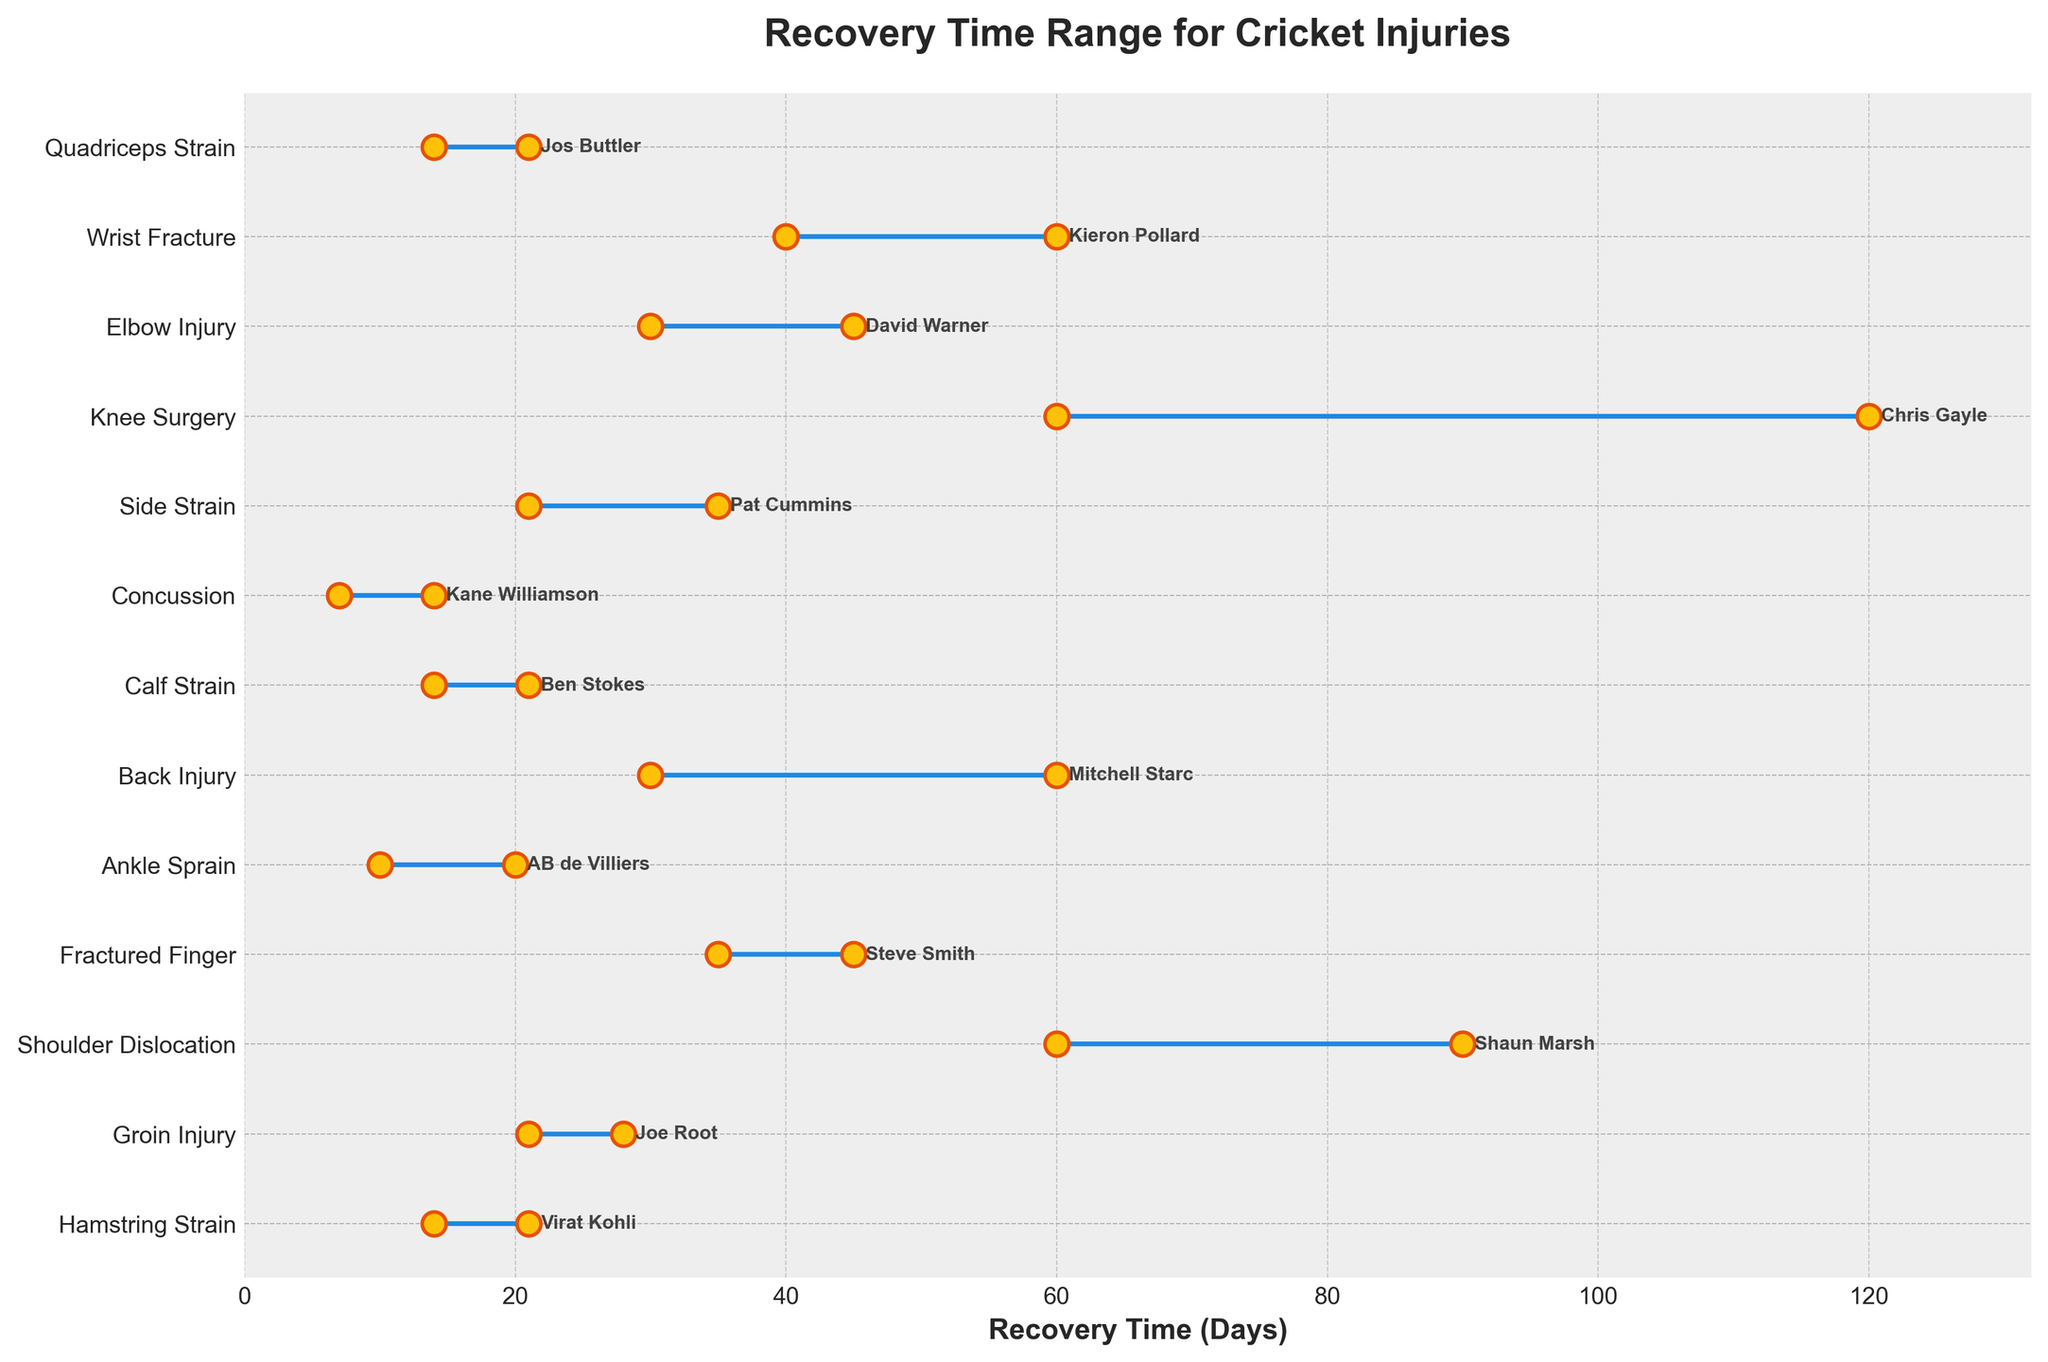What injury type has the longest maximum recovery time? To find the injury type with the longest maximum recovery time, look at the right endpoint of the ranges. The injury type with the highest maximum value is Knee Surgery, which has a maximum recovery time of 120 days.
Answer: Knee Surgery What is the shortest minimum recovery time shown in the plot? To find the shortest minimum recovery time, look at the left endpoint of the ranges. The lowest minimum recovery time is for Concussion, which is 7 days.
Answer: Concussion Which player has the broadest range of recovery times, and what is that range? To find the player with the broadest range, calculate the difference between the maximum and minimum recovery times for each player. The largest difference is for Chris Gayle (Knee Surgery), spanning from 60 to 120 days, which is a range of 60 days.
Answer: Chris Gayle, 60 days How many injury types have a maximum recovery time of more than 60 days? Count the number of injuries with a maximum recovery time greater than 60 days. These include Shoulder Dislocation, Knee Surgery, Back Injury, and Wrist Fracture, totaling 4 injury types.
Answer: 4 injury types Which player's recovery times wholly fit within the 10 to 20 days range? Look at the players whose minimum and maximum recovery times are between 10 and 20 days. Both AB de Villiers (Ankle Sprain) and Kane Williamson (Concussion) have recovery times that fit within this range.
Answer: AB de Villiers, Kane Williamson Calculate the average maximum recovery time for Fractured Finger and Wrist Fracture. First, identify the maximum recovery times: Fractured Finger (45 days), Wrist Fracture (60 days). Sum these maximum times (45 + 60 = 105) and divide by 2 to get the average: 105 / 2 = 52.5 days.
Answer: 52.5 days Compared to Ben Stokes (Calf Strain), how much longer is Mitchell Starc's (Back Injury) maximum recovery time? Find the difference between Mitchell Starc's maximum recovery time (60 days) and Ben Stokes' maximum recovery time (21 days). The difference is 60 - 21 = 39 days.
Answer: 39 days What is the median maximum recovery time of all injuries? List the maximum recovery times in ascending order: 14, 14, 20, 21, 21, 28, 35, 45, 45, 60, 60, 90, 120. The median is the middle value in an odd-length list, so the 7th value is 35.
Answer: 35 days 